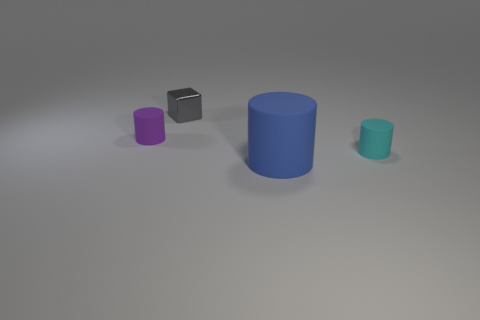What size is the thing that is both on the left side of the cyan rubber object and right of the small shiny object?
Make the answer very short. Large. There is a matte cylinder behind the cyan rubber object in front of the metal object; what color is it?
Ensure brevity in your answer.  Purple. Are there fewer tiny blocks that are left of the tiny block than metallic things that are behind the tiny cyan matte thing?
Provide a short and direct response. Yes. Do the purple rubber cylinder and the cyan object have the same size?
Ensure brevity in your answer.  Yes. The tiny thing that is in front of the small metallic object and behind the small cyan rubber object has what shape?
Make the answer very short. Cylinder. What number of large purple blocks are made of the same material as the small cyan cylinder?
Your answer should be very brief. 0. What number of gray shiny blocks are behind the thing right of the large cylinder?
Make the answer very short. 1. The small matte object that is behind the tiny matte thing in front of the rubber cylinder left of the shiny block is what shape?
Your answer should be very brief. Cylinder. What number of things are either cyan rubber cylinders or tiny purple objects?
Give a very brief answer. 2. What color is the other shiny object that is the same size as the cyan object?
Your answer should be very brief. Gray. 